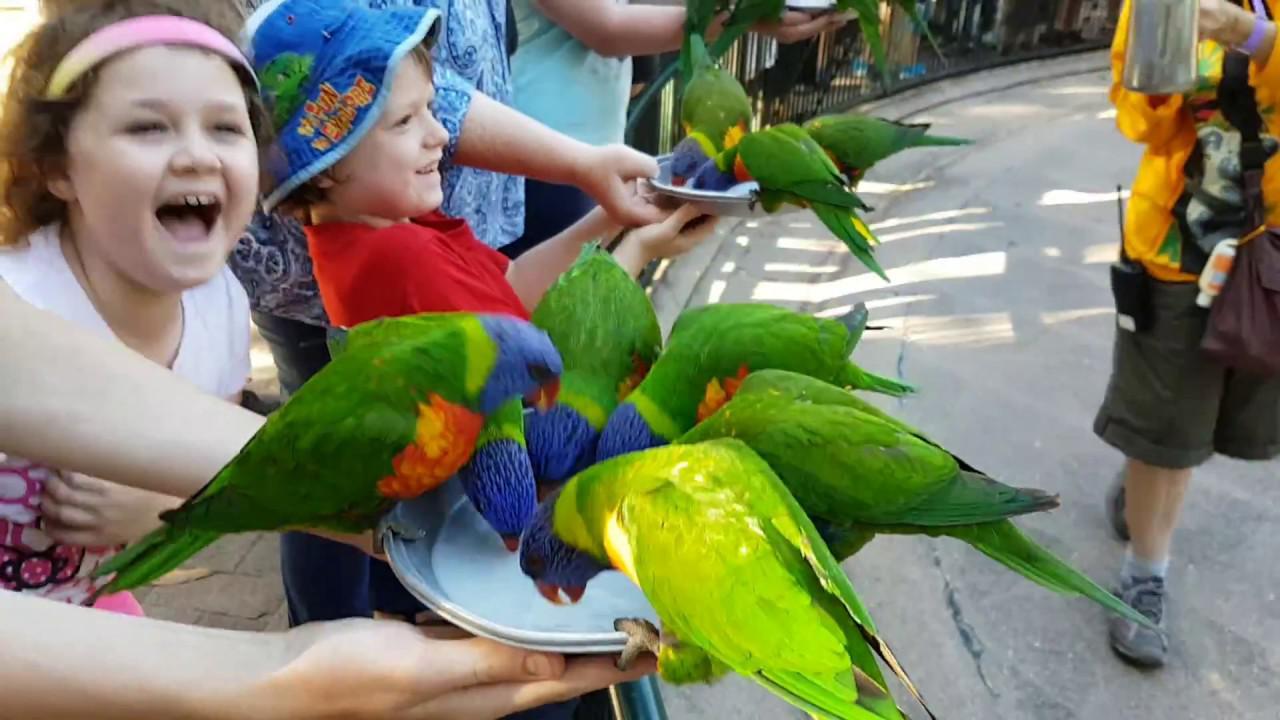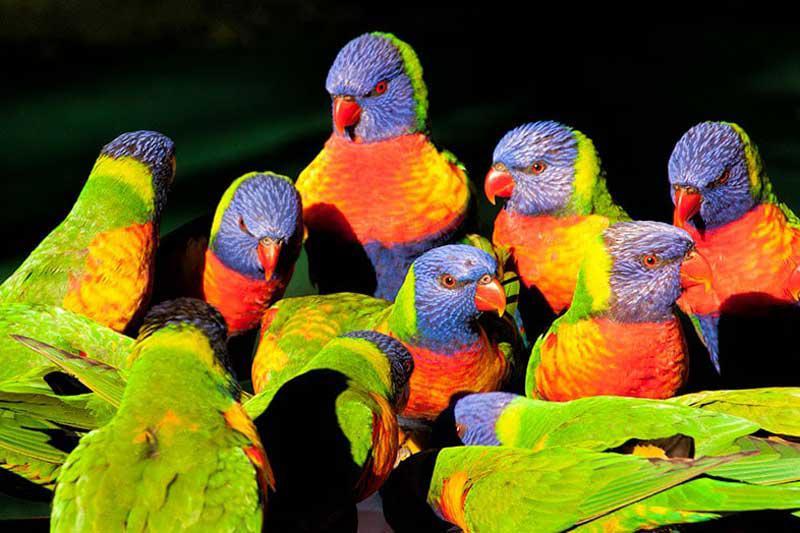The first image is the image on the left, the second image is the image on the right. Examine the images to the left and right. Is the description "There are lorikeets drinking from a silver, handheld bowl in the left image." accurate? Answer yes or no. Yes. The first image is the image on the left, the second image is the image on the right. Given the left and right images, does the statement "Left image shows a hand holding a round pan from which multi-colored birds drink." hold true? Answer yes or no. Yes. 